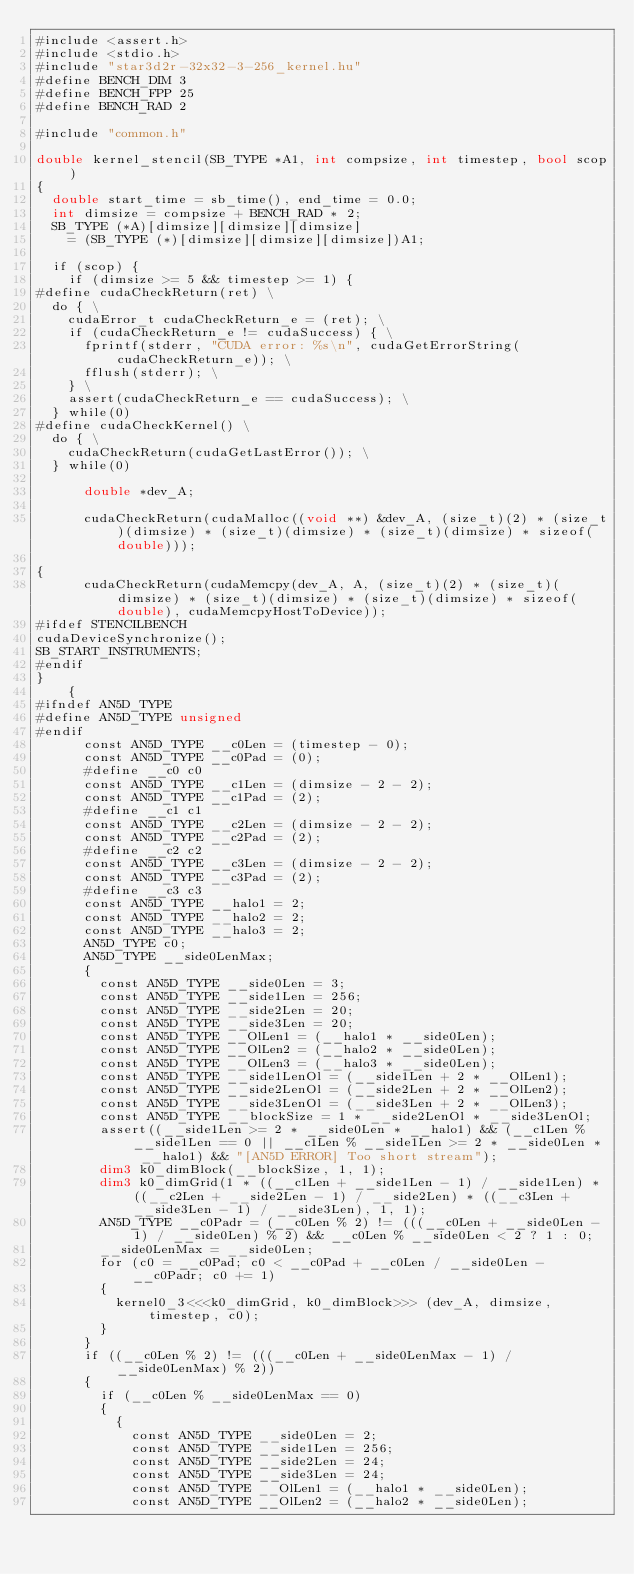Convert code to text. <code><loc_0><loc_0><loc_500><loc_500><_Cuda_>#include <assert.h>
#include <stdio.h>
#include "star3d2r-32x32-3-256_kernel.hu"
#define BENCH_DIM 3
#define BENCH_FPP 25
#define BENCH_RAD 2

#include "common.h"

double kernel_stencil(SB_TYPE *A1, int compsize, int timestep, bool scop)
{
  double start_time = sb_time(), end_time = 0.0;
  int dimsize = compsize + BENCH_RAD * 2;
  SB_TYPE (*A)[dimsize][dimsize][dimsize]
    = (SB_TYPE (*)[dimsize][dimsize][dimsize])A1;

  if (scop) {
    if (dimsize >= 5 && timestep >= 1) {
#define cudaCheckReturn(ret) \
  do { \
    cudaError_t cudaCheckReturn_e = (ret); \
    if (cudaCheckReturn_e != cudaSuccess) { \
      fprintf(stderr, "CUDA error: %s\n", cudaGetErrorString(cudaCheckReturn_e)); \
      fflush(stderr); \
    } \
    assert(cudaCheckReturn_e == cudaSuccess); \
  } while(0)
#define cudaCheckKernel() \
  do { \
    cudaCheckReturn(cudaGetLastError()); \
  } while(0)

      double *dev_A;
      
      cudaCheckReturn(cudaMalloc((void **) &dev_A, (size_t)(2) * (size_t)(dimsize) * (size_t)(dimsize) * (size_t)(dimsize) * sizeof(double)));
      
{
      cudaCheckReturn(cudaMemcpy(dev_A, A, (size_t)(2) * (size_t)(dimsize) * (size_t)(dimsize) * (size_t)(dimsize) * sizeof(double), cudaMemcpyHostToDevice));
#ifdef STENCILBENCH
cudaDeviceSynchronize();
SB_START_INSTRUMENTS;
#endif
}
    {
#ifndef AN5D_TYPE
#define AN5D_TYPE unsigned
#endif
      const AN5D_TYPE __c0Len = (timestep - 0);
      const AN5D_TYPE __c0Pad = (0);
      #define __c0 c0
      const AN5D_TYPE __c1Len = (dimsize - 2 - 2);
      const AN5D_TYPE __c1Pad = (2);
      #define __c1 c1
      const AN5D_TYPE __c2Len = (dimsize - 2 - 2);
      const AN5D_TYPE __c2Pad = (2);
      #define __c2 c2
      const AN5D_TYPE __c3Len = (dimsize - 2 - 2);
      const AN5D_TYPE __c3Pad = (2);
      #define __c3 c3
      const AN5D_TYPE __halo1 = 2;
      const AN5D_TYPE __halo2 = 2;
      const AN5D_TYPE __halo3 = 2;
      AN5D_TYPE c0;
      AN5D_TYPE __side0LenMax;
      {
        const AN5D_TYPE __side0Len = 3;
        const AN5D_TYPE __side1Len = 256;
        const AN5D_TYPE __side2Len = 20;
        const AN5D_TYPE __side3Len = 20;
        const AN5D_TYPE __OlLen1 = (__halo1 * __side0Len);
        const AN5D_TYPE __OlLen2 = (__halo2 * __side0Len);
        const AN5D_TYPE __OlLen3 = (__halo3 * __side0Len);
        const AN5D_TYPE __side1LenOl = (__side1Len + 2 * __OlLen1);
        const AN5D_TYPE __side2LenOl = (__side2Len + 2 * __OlLen2);
        const AN5D_TYPE __side3LenOl = (__side3Len + 2 * __OlLen3);
        const AN5D_TYPE __blockSize = 1 * __side2LenOl * __side3LenOl;
        assert((__side1Len >= 2 * __side0Len * __halo1) && (__c1Len % __side1Len == 0 || __c1Len % __side1Len >= 2 * __side0Len * __halo1) && "[AN5D ERROR] Too short stream");
        dim3 k0_dimBlock(__blockSize, 1, 1);
        dim3 k0_dimGrid(1 * ((__c1Len + __side1Len - 1) / __side1Len) * ((__c2Len + __side2Len - 1) / __side2Len) * ((__c3Len + __side3Len - 1) / __side3Len), 1, 1);
        AN5D_TYPE __c0Padr = (__c0Len % 2) != (((__c0Len + __side0Len - 1) / __side0Len) % 2) && __c0Len % __side0Len < 2 ? 1 : 0;
        __side0LenMax = __side0Len;
        for (c0 = __c0Pad; c0 < __c0Pad + __c0Len / __side0Len - __c0Padr; c0 += 1)
        {
          kernel0_3<<<k0_dimGrid, k0_dimBlock>>> (dev_A, dimsize, timestep, c0);
        }
      }
      if ((__c0Len % 2) != (((__c0Len + __side0LenMax - 1) / __side0LenMax) % 2))
      {
        if (__c0Len % __side0LenMax == 0)
        {
          {
            const AN5D_TYPE __side0Len = 2;
            const AN5D_TYPE __side1Len = 256;
            const AN5D_TYPE __side2Len = 24;
            const AN5D_TYPE __side3Len = 24;
            const AN5D_TYPE __OlLen1 = (__halo1 * __side0Len);
            const AN5D_TYPE __OlLen2 = (__halo2 * __side0Len);</code> 